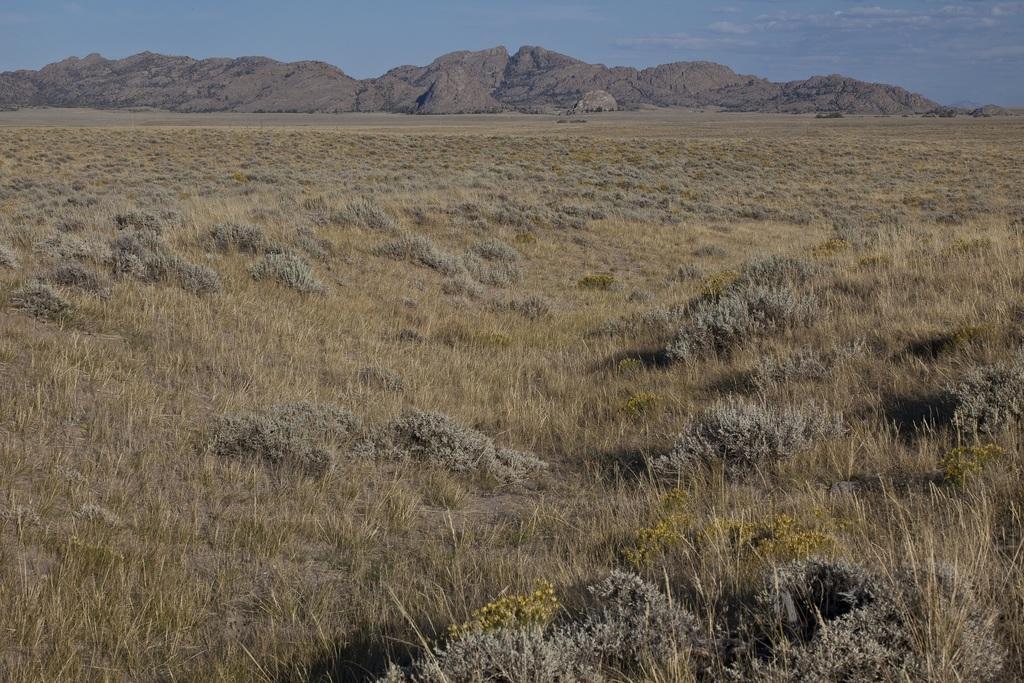How would you summarize this image in a sentence or two? In this image I can see the grass. In the background, I can see the hills and clouds in the sky. 